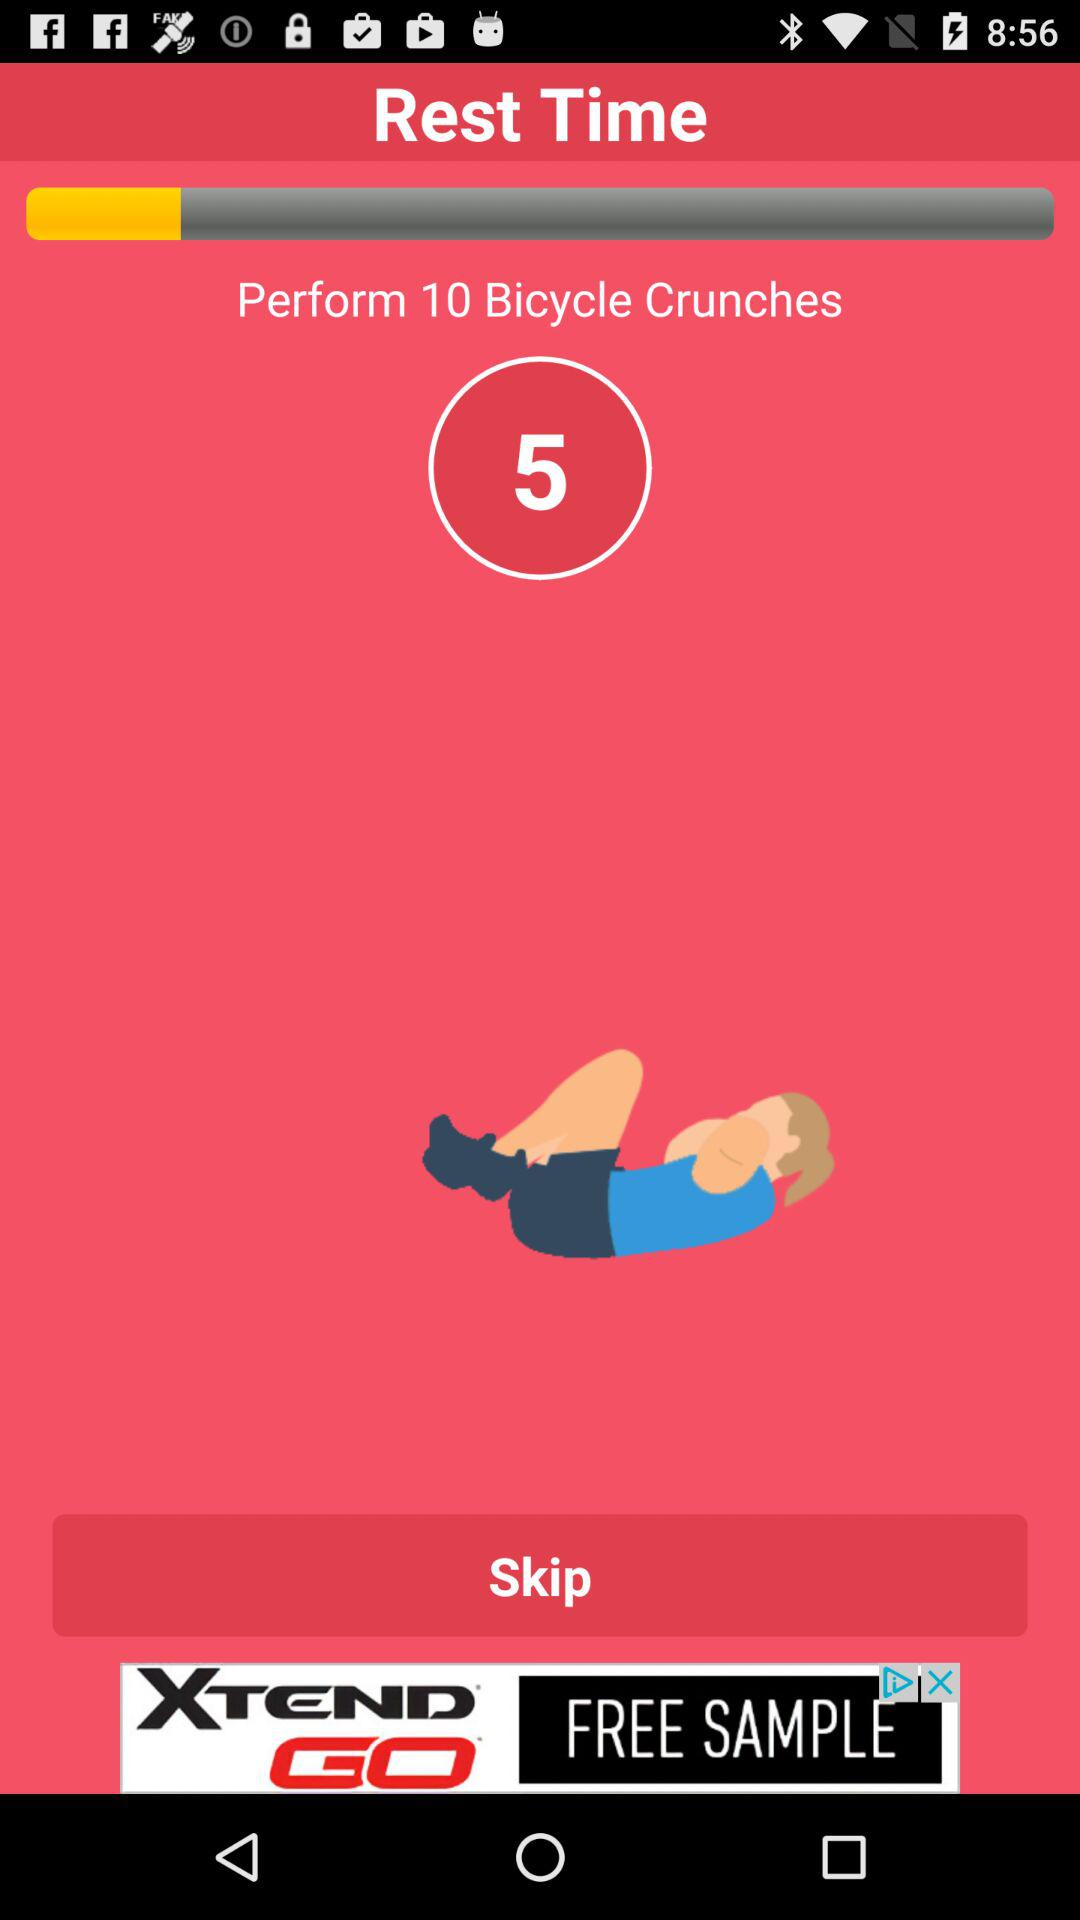How many more bicycle crunches do I need to do than rest time?
Answer the question using a single word or phrase. 10 